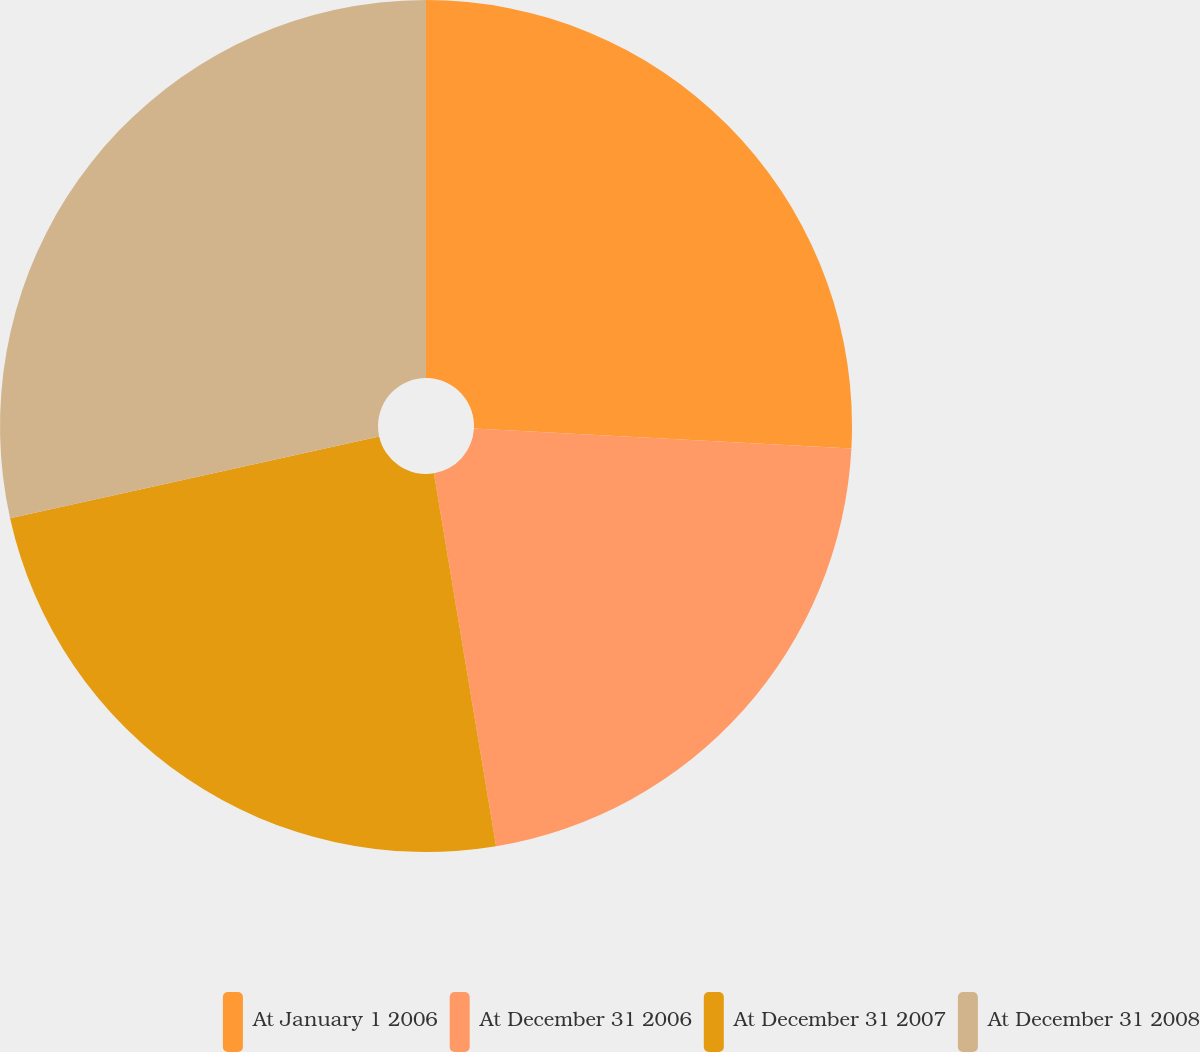<chart> <loc_0><loc_0><loc_500><loc_500><pie_chart><fcel>At January 1 2006<fcel>At December 31 2006<fcel>At December 31 2007<fcel>At December 31 2008<nl><fcel>25.84%<fcel>21.53%<fcel>24.16%<fcel>28.47%<nl></chart> 